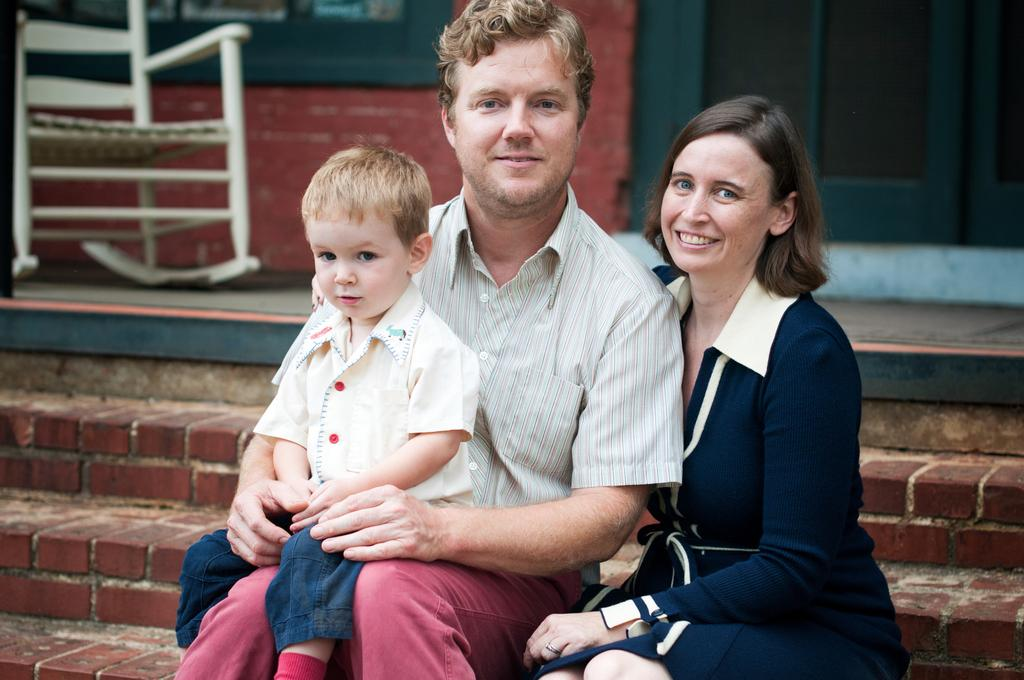Who is present in the image? There is a couple and a kid in the image. What are they doing in the image? The couple and the kid are sitting on stairs. What is their facial expression in the image? They are looking and smiling at someone. What type of statement is the kid making in the image? There is no indication in the image that the kid is making a statement, as the focus is on their facial expression and location. 